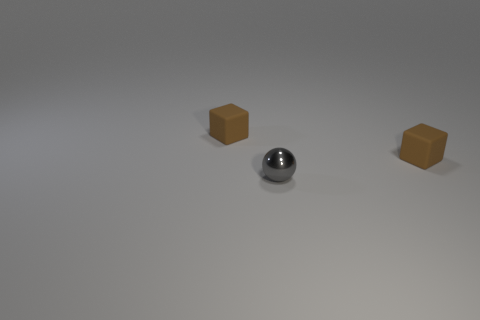Add 1 small gray objects. How many objects exist? 4 Subtract all spheres. How many objects are left? 2 Subtract 0 purple cylinders. How many objects are left? 3 Subtract all tiny brown objects. Subtract all tiny gray spheres. How many objects are left? 0 Add 1 small things. How many small things are left? 4 Add 3 yellow metal spheres. How many yellow metal spheres exist? 3 